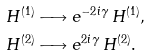Convert formula to latex. <formula><loc_0><loc_0><loc_500><loc_500>H ^ { ( 1 ) } & \longrightarrow e ^ { - 2 i \gamma } \, H ^ { ( 1 ) } , \\ H ^ { ( 2 ) } & \longrightarrow e ^ { 2 i \gamma } \, H ^ { ( 2 ) } .</formula> 